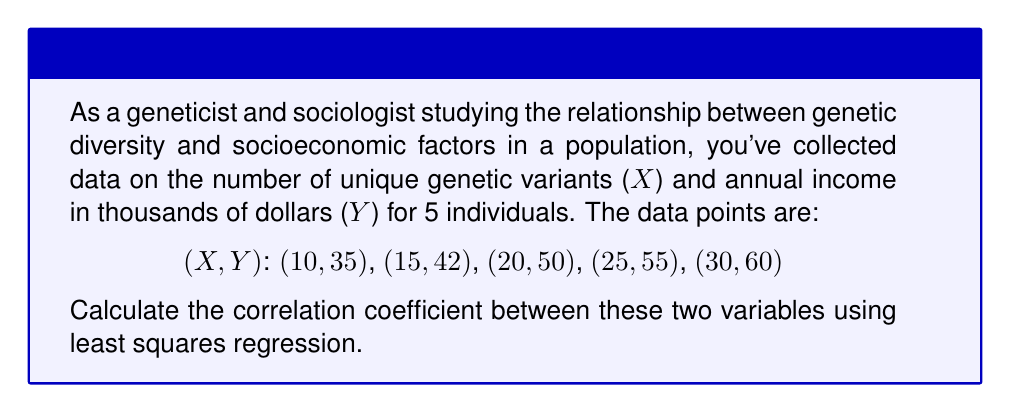Teach me how to tackle this problem. To calculate the correlation coefficient using least squares regression, we'll follow these steps:

1. Calculate the means of X and Y:
   $$\bar{X} = \frac{10 + 15 + 20 + 25 + 30}{5} = 20$$
   $$\bar{Y} = \frac{35 + 42 + 50 + 55 + 60}{5} = 48.4$$

2. Calculate the sums of squares:
   $$SS_{xx} = \sum(X_i - \bar{X})^2 = 200$$
   $$SS_{yy} = \sum(Y_i - \bar{Y})^2 = 294.8$$
   $$SS_{xy} = \sum(X_i - \bar{X})(Y_i - \bar{Y}) = 240$$

3. Calculate the slope (b) of the regression line:
   $$b = \frac{SS_{xy}}{SS_{xx}} = \frac{240}{200} = 1.2$$

4. Calculate the y-intercept (a) of the regression line:
   $$a = \bar{Y} - b\bar{X} = 48.4 - 1.2(20) = 24.4$$

5. The regression line equation is:
   $$Y = 24.4 + 1.2X$$

6. Calculate the correlation coefficient (r):
   $$r = \frac{SS_{xy}}{\sqrt{SS_{xx} \cdot SS_{yy}}} = \frac{240}{\sqrt{200 \cdot 294.8}} \approx 0.9897$$

The correlation coefficient ranges from -1 to 1, where 1 indicates a perfect positive linear relationship, -1 indicates a perfect negative linear relationship, and 0 indicates no linear relationship.
Answer: $r \approx 0.9897$ 